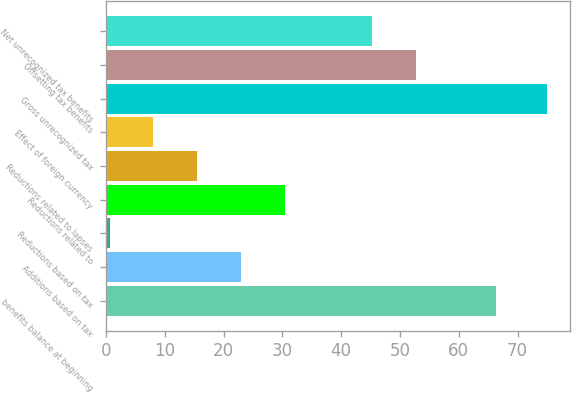Convert chart to OTSL. <chart><loc_0><loc_0><loc_500><loc_500><bar_chart><fcel>benefits balance at beginning<fcel>Additions based on tax<fcel>Reductions based on tax<fcel>Reductions related to<fcel>Reductions related to lapses<fcel>Effect of foreign currency<fcel>Gross unrecognized tax<fcel>Offsetting tax benefits<fcel>Net unrecognized tax benefits<nl><fcel>66.3<fcel>22.95<fcel>0.6<fcel>30.4<fcel>15.5<fcel>8.05<fcel>75.1<fcel>52.75<fcel>45.3<nl></chart> 